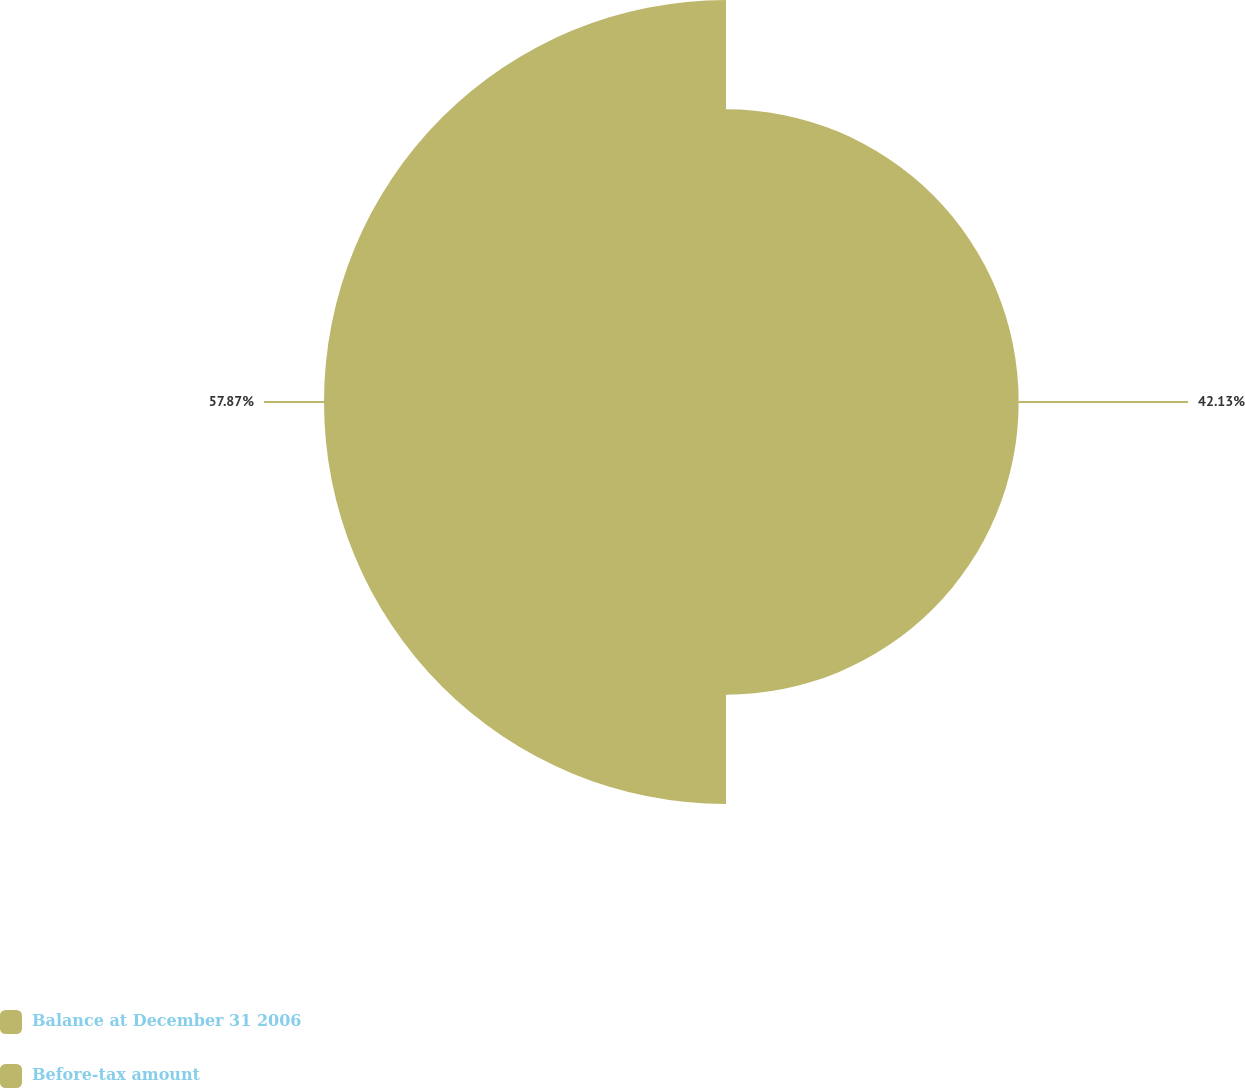<chart> <loc_0><loc_0><loc_500><loc_500><pie_chart><fcel>Balance at December 31 2006<fcel>Before-tax amount<nl><fcel>42.13%<fcel>57.87%<nl></chart> 